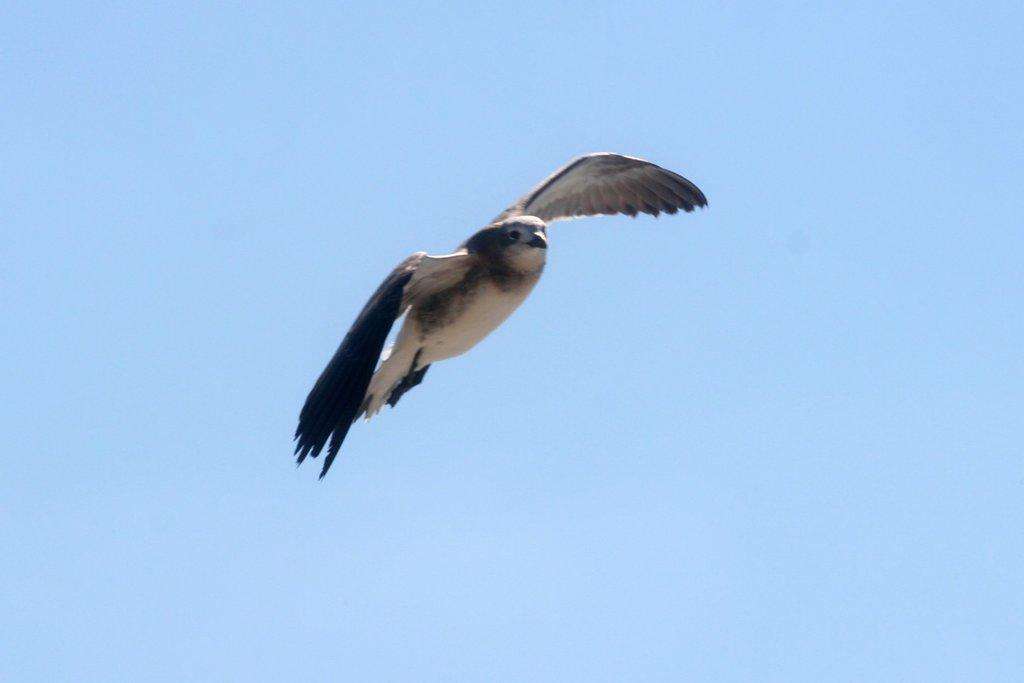What type of animal can be seen in the image? There is a bird in the image. What is the bird doing in the image? The bird is flying in the sky. What color is the mitten that the bird is holding in the image? There is no mitten present in the image, and the bird is not holding anything. 